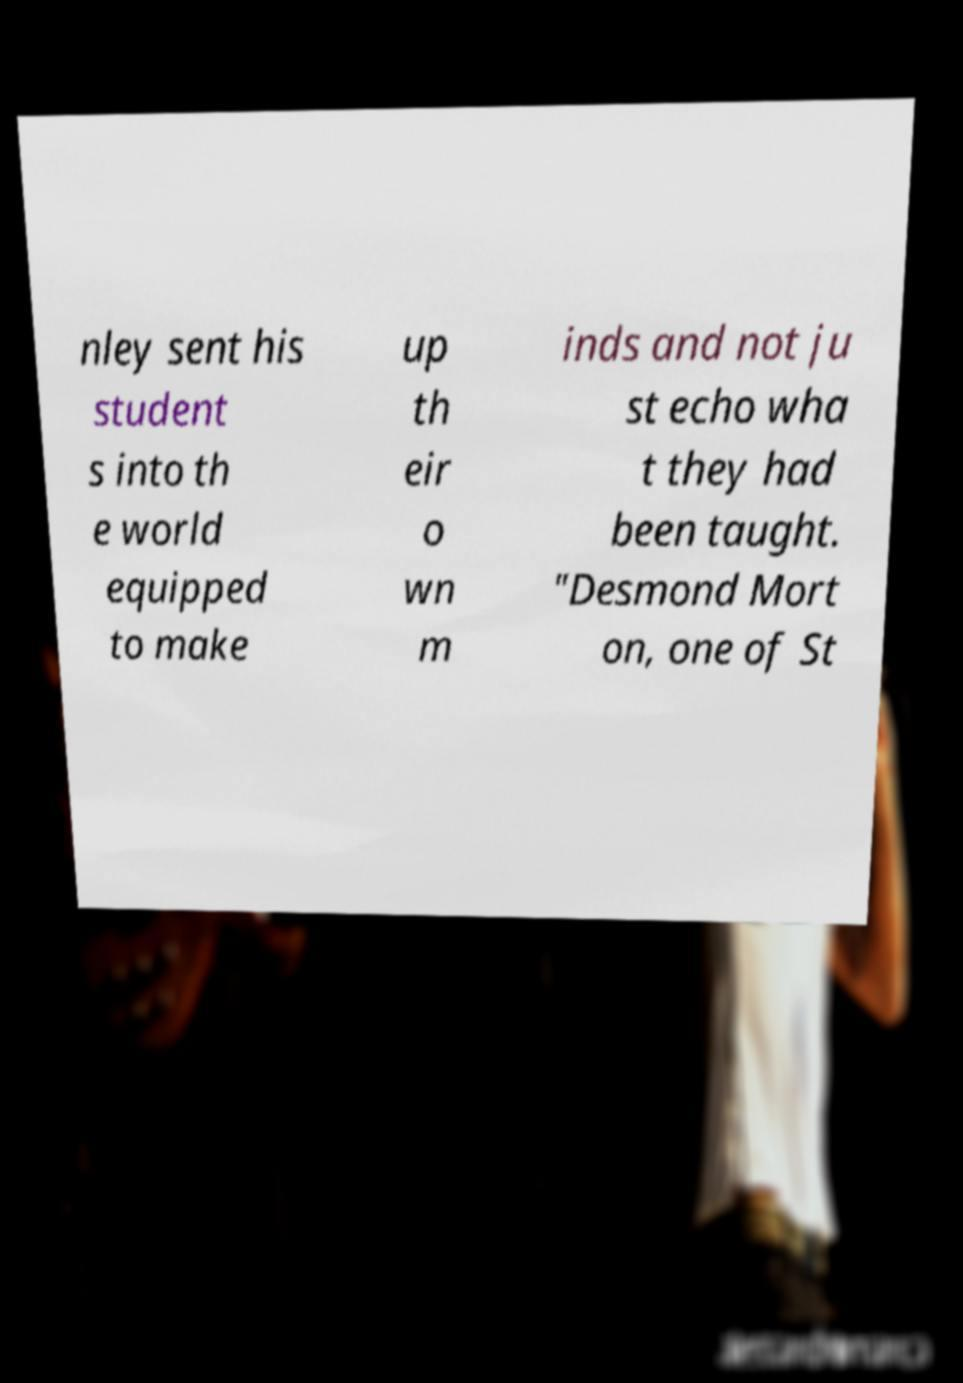Could you assist in decoding the text presented in this image and type it out clearly? nley sent his student s into th e world equipped to make up th eir o wn m inds and not ju st echo wha t they had been taught. "Desmond Mort on, one of St 